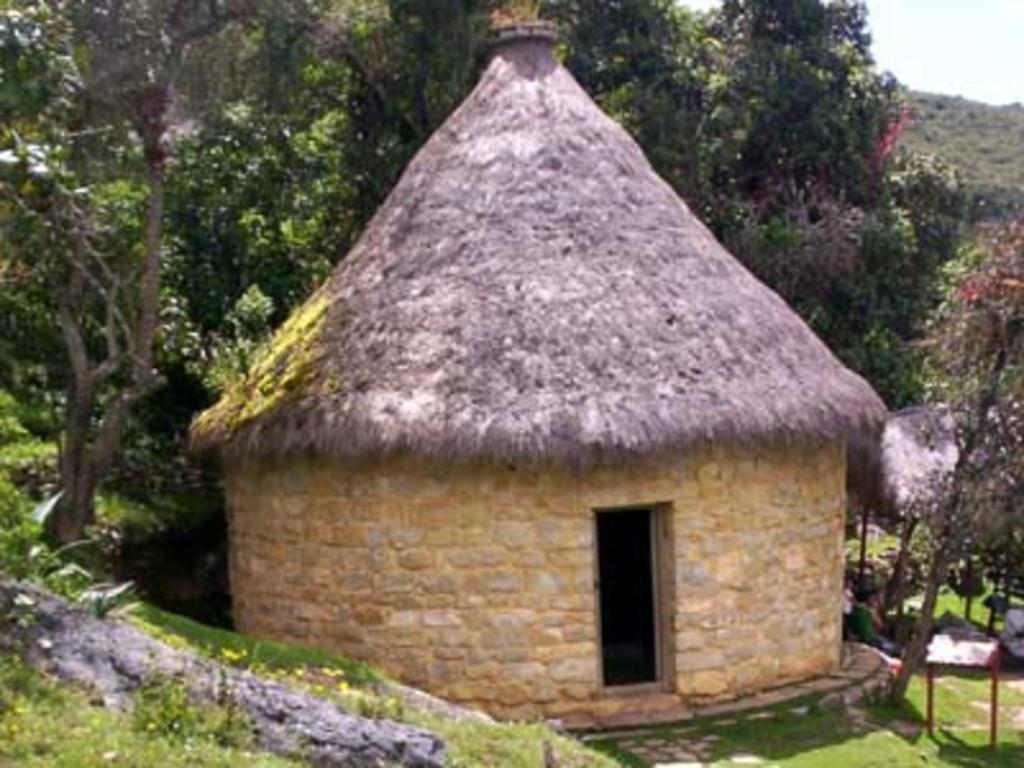Could you give a brief overview of what you see in this image? In this picture I can see a hut. I can see few persons, and in the background there are trees and the sky. 